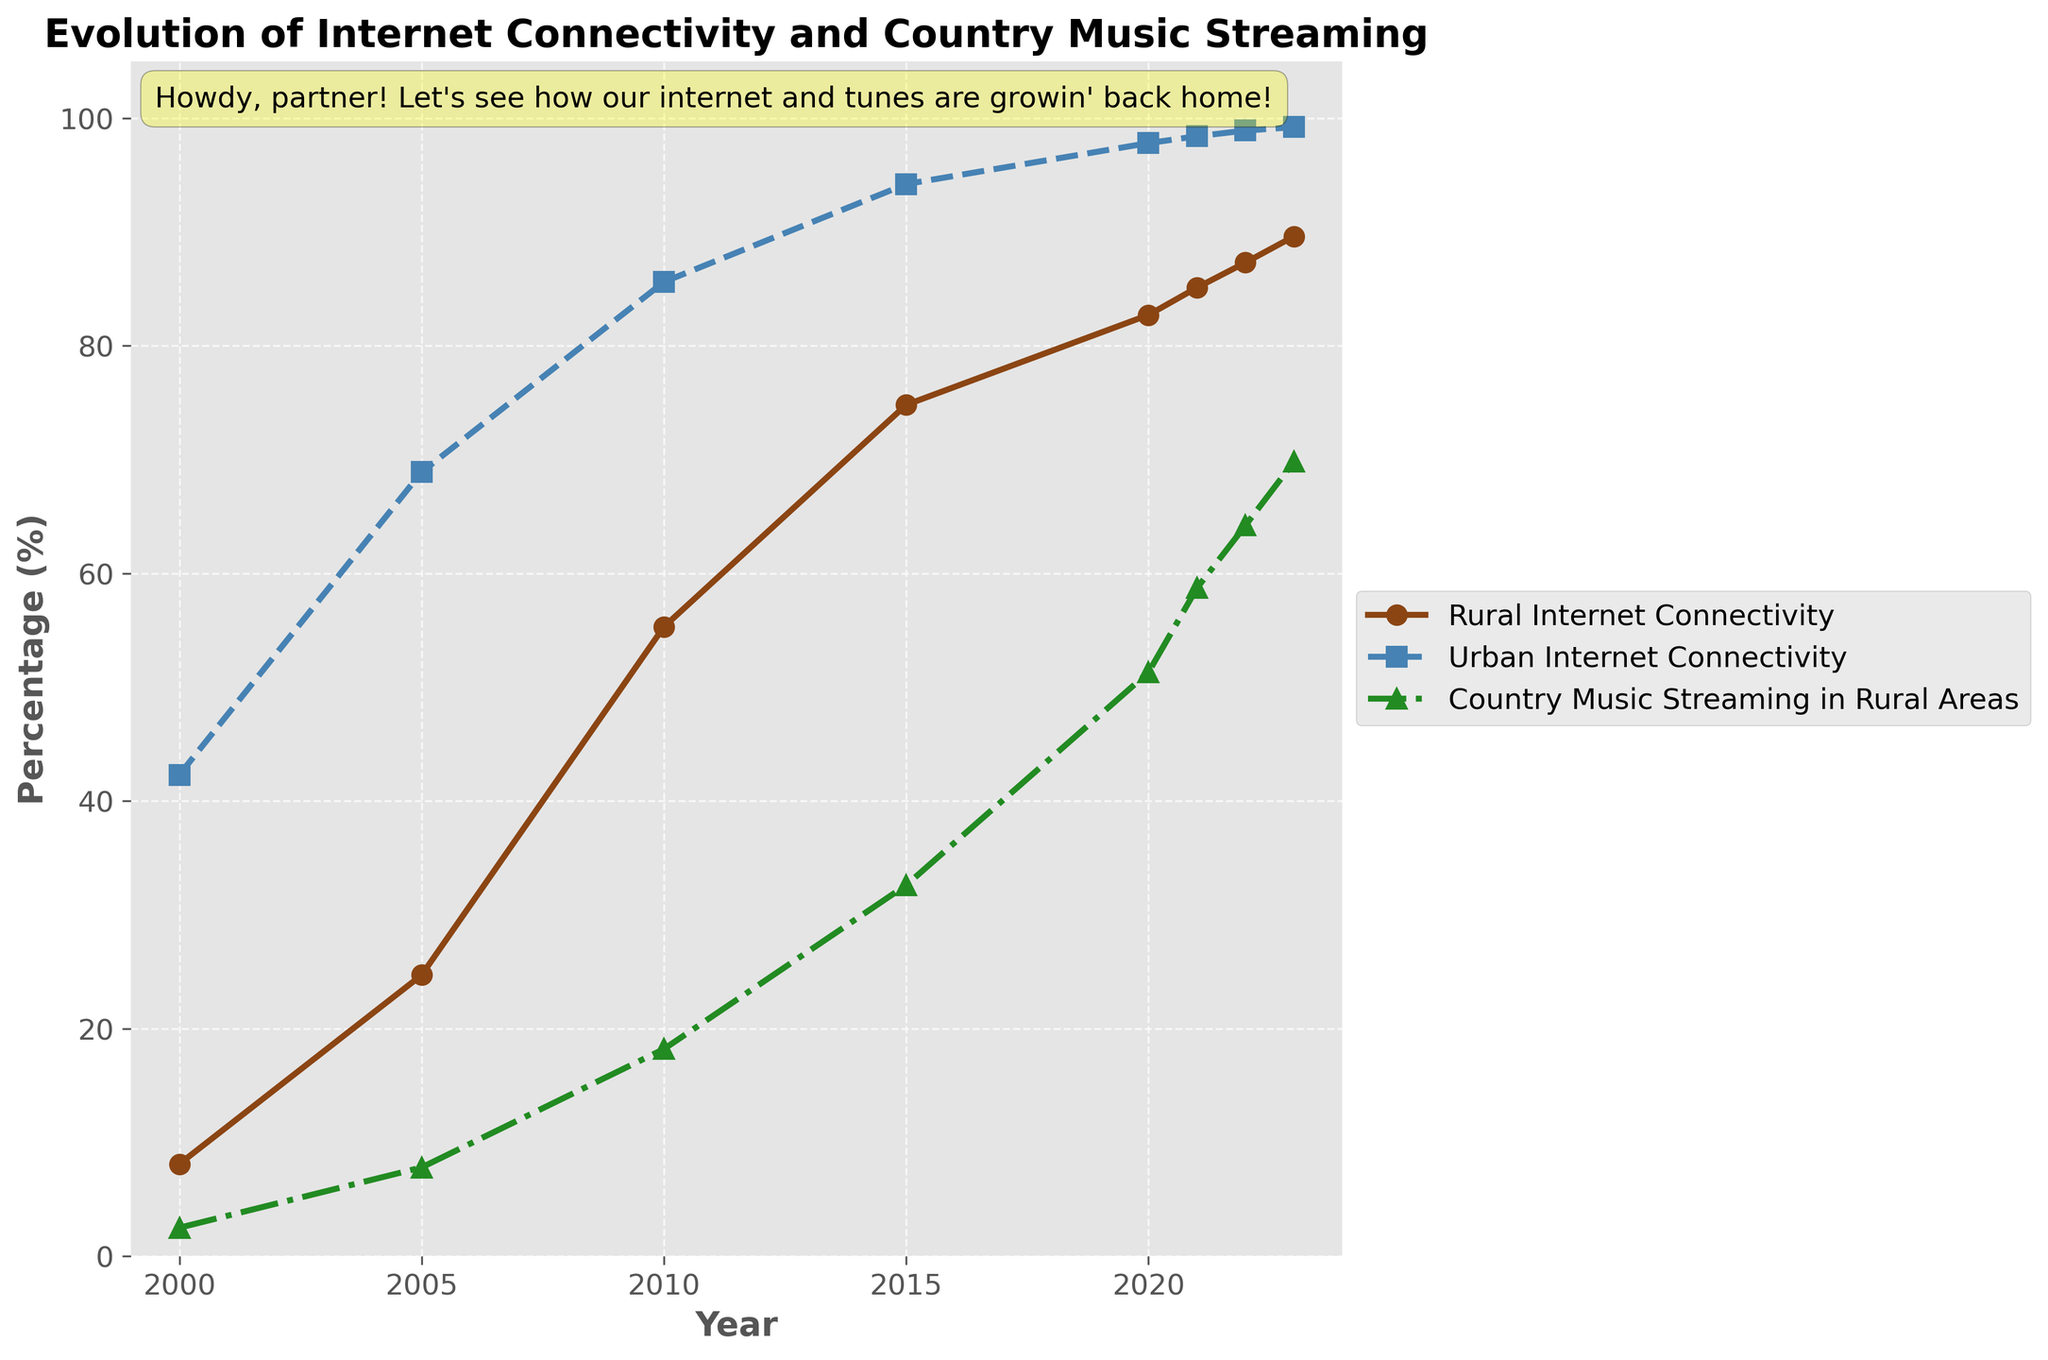What's the trend of rural internet connectivity from 2000 to 2023? Rural internet connectivity shows a steady increase from 8.1% in 2000 to 89.6% in 2023, growing almost every year.
Answer: Increasing trend Which year had the greatest difference between rural and urban internet connectivity rates? The greatest difference between rural and urban internet connectivity rates occurs in 2000, where the difference is 42.3% - 8.1% = 34.2%.
Answer: 2000 How does the increase in country music streaming in rural areas compare to the increase in rural internet connectivity from 2000 to 2023? The increase in rural internet connectivity from 2000 to 2023 is 89.6% - 8.1% = 81.5%. For country music streaming, it increased from 2.5% to 69.8%, giving an increase of 69.8% - 2.5% = 67.3%. Therefore, rural internet connectivity increased by more.
Answer: Rural internet connectivity increased more Compare the percentage of country music streaming in rural areas in 2010 and 2020. In 2010, the percentage of country music streaming in rural areas is 18.2%, and in 2020 it is 51.3%. So, 51.3% - 18.2% = 33.1% increase.
Answer: 33.1% increase What are the colors used for the lines representing rural internet connectivity and country music streaming in the figure? The line representing rural internet connectivity is brown, and the line for country music streaming in rural areas is green.
Answer: Brown and green What was the percentage change in urban internet connectivity from 2005 to 2023? The percentage of urban internet connectivity in 2005 is 68.9% and in 2023 is 99.2%. The percentage change is (99.2% - 68.9%) / 68.9% * 100 = 43.9%.
Answer: 43.9% Compare the percentages of rural internet connectivity and country music streaming in rural areas in 2023. In 2023, rural internet connectivity is 89.6% and country music streaming in rural areas is 69.8%. Therefore, rural internet connectivity is higher.
Answer: Rural internet connectivity is higher In which year did rural internet connectivity first exceed 70%? Rural internet connectivity first exceeded 70% in 2015 when it reached 74.8%.
Answer: 2015 By how much did rural internet connectivity grow in the decade from 2010 to 2020? Rural internet connectivity in 2010 was 55.3%, and in 2020 it was 82.7%. The growth over the decade is 82.7% - 55.3% = 27.4%.
Answer: 27.4% 